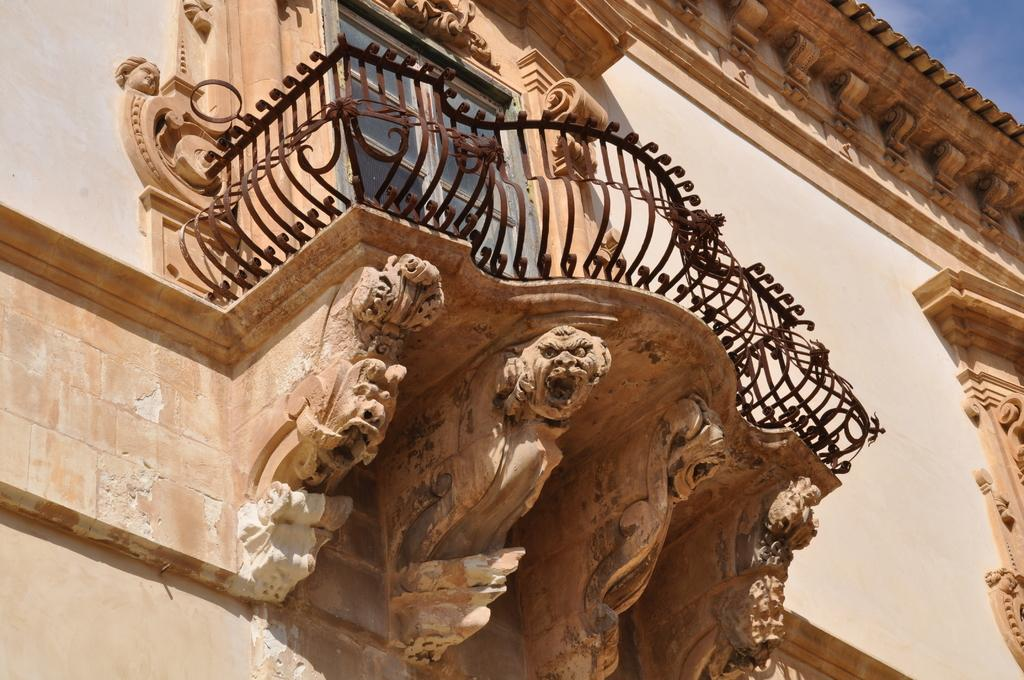What type of barrier is present in the image? There is an iron fence in the image. What is located behind the iron fence? There is a glass door behind the iron fence. What type of artwork can be seen on the walls in the image? There are sculptures on the walls in the image. What color is the daughter's dress in the image? There is no daughter present in the image, so it is not possible to answer that question. 